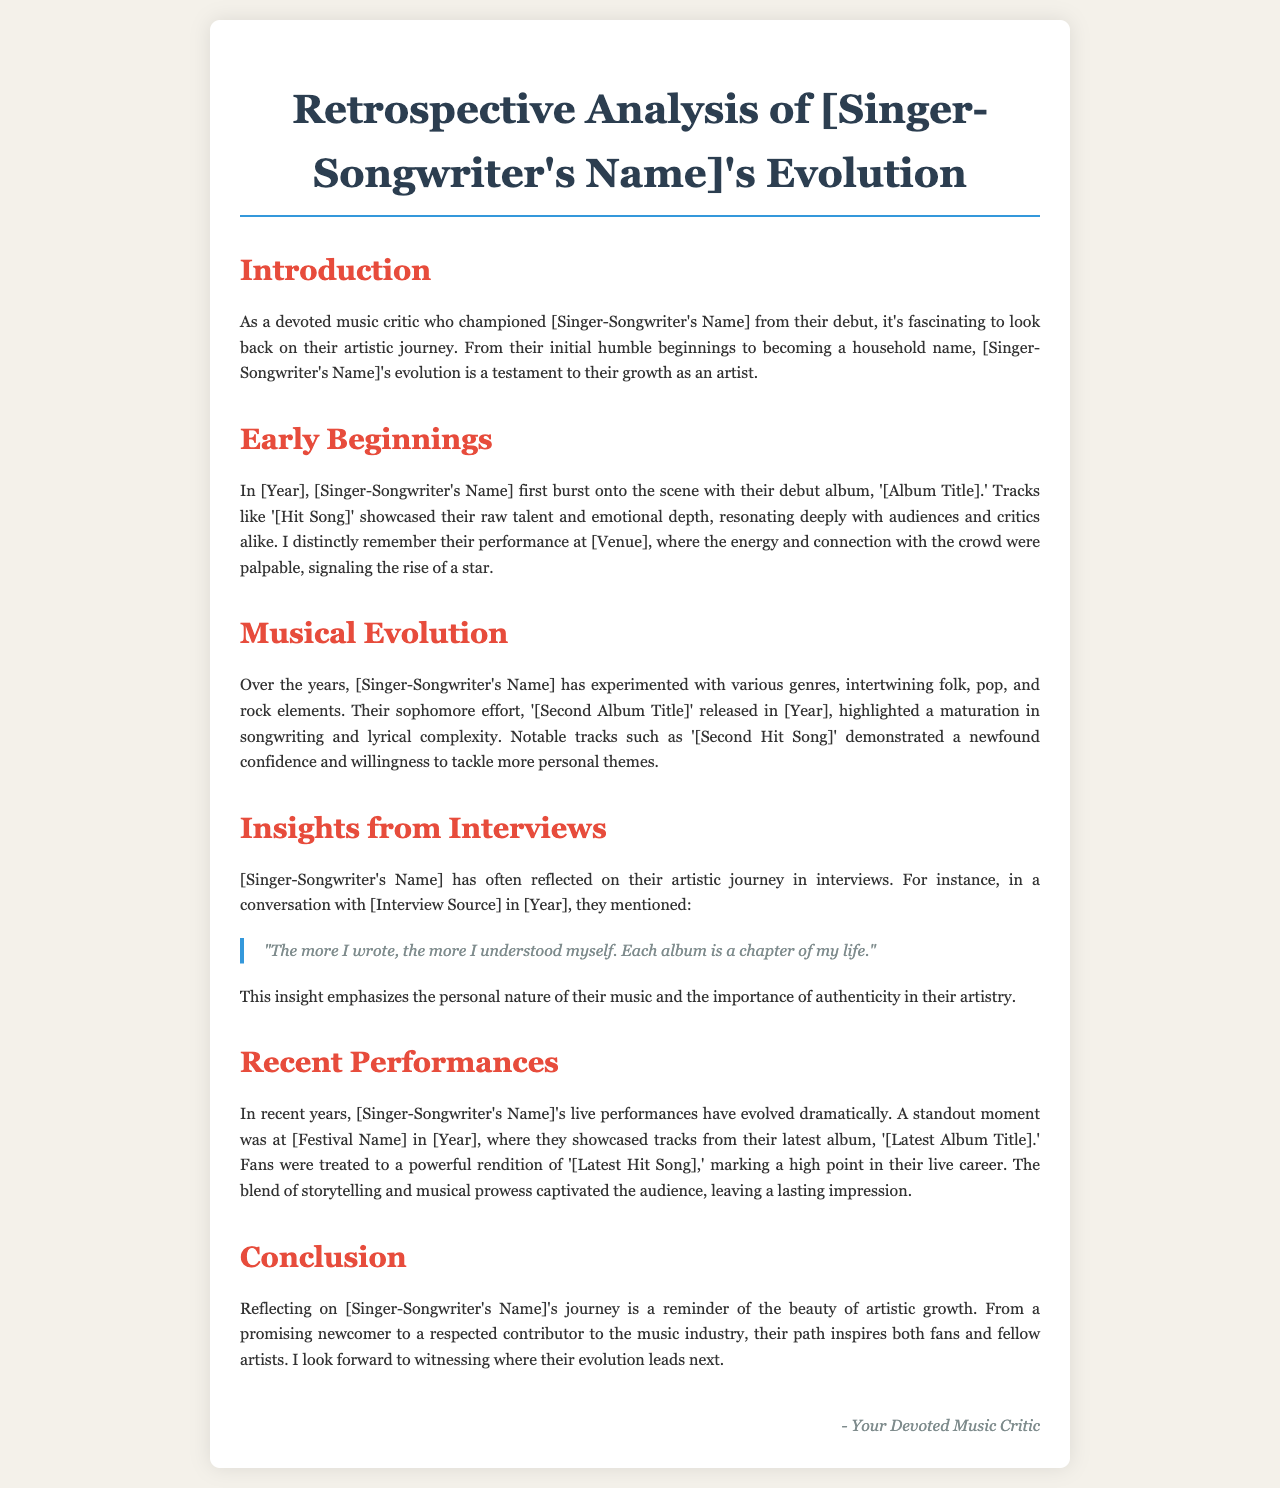What is the singer-songwriter's debut album title? The debut album is titled '[Album Title]', which marked the beginning of their career.
Answer: [Album Title] In what year did [Singer-Songwriter's Name] release their sophomore album? The document states that the sophomore album, '[Second Album Title]', was released in [Year].
Answer: [Year] What was the standout event mentioned for recent performances? The standout event is mentioned as [Festival Name] in [Year], showcasing tracks from their latest album.
Answer: [Festival Name] Which song showcased the singer-songwriter's raw talent? The song '[Hit Song]' is specifically mentioned as showcasing the singer-songwriter's raw talent and emotional depth.
Answer: [Hit Song] What does the featured quote from the interview emphasize? The quote emphasizes the personal nature of their music and the importance of authenticity in their artistry.
Answer: authenticity How does the document describe the singer-songwriter's evolution? It describes the evolution as a testament to their growth as an artist over the years.
Answer: growth What genre blend does the singer-songwriter experiment with? They experiment with a blend of folk, pop, and rock elements in their music.
Answer: folk, pop, and rock What year did [Singer-Songwriter's Name] first burst onto the scene? The document begins with stating their debut in [Year].
Answer: [Year] What is the title of the latest album mentioned? The title of the latest album is '[Latest Album Title]', which reflects the artist's recent work.
Answer: [Latest Album Title] 